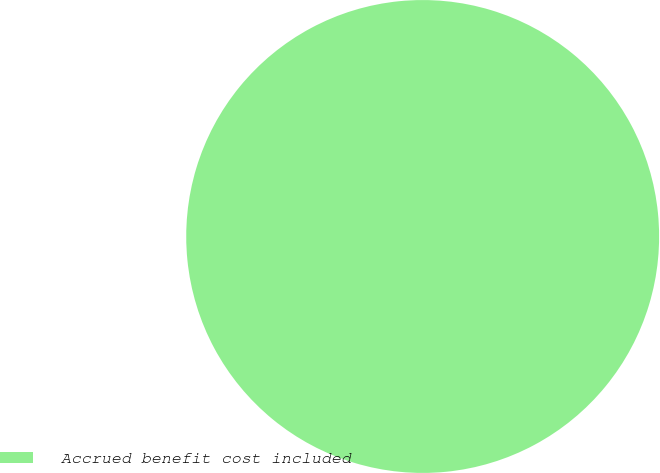Convert chart to OTSL. <chart><loc_0><loc_0><loc_500><loc_500><pie_chart><fcel>Accrued benefit cost included<nl><fcel>100.0%<nl></chart> 